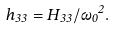<formula> <loc_0><loc_0><loc_500><loc_500>h _ { 3 3 } = H _ { 3 3 } / { \omega _ { 0 } } ^ { 2 } .</formula> 